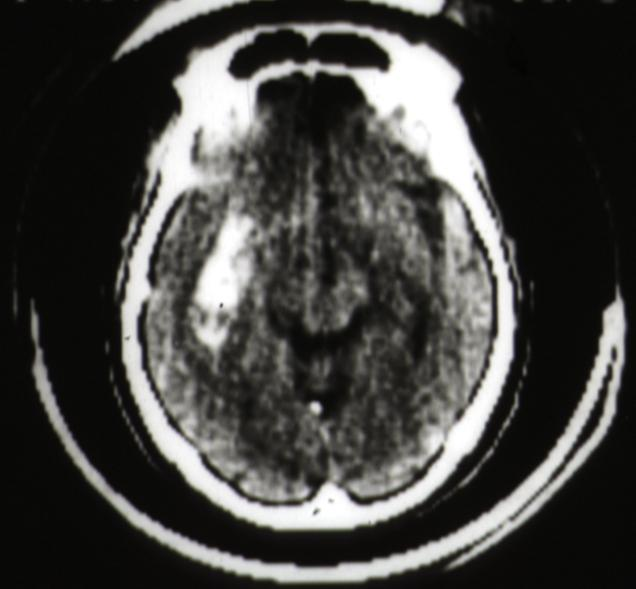what does this image show?
Answer the question using a single word or phrase. Cat scan putamen hemorrhage 